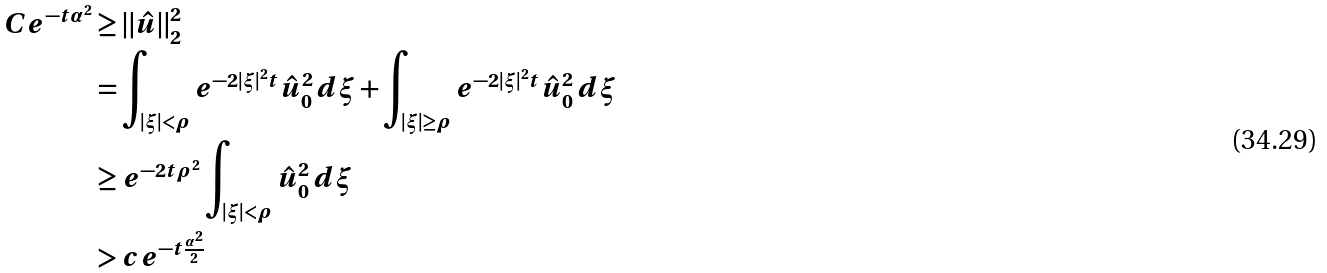<formula> <loc_0><loc_0><loc_500><loc_500>C e ^ { - t \alpha ^ { 2 } } & \geq \| \hat { u } \| _ { 2 } ^ { 2 } \\ & = \int _ { | \xi | < \rho } e ^ { - 2 | \xi | ^ { 2 } t } \hat { u } _ { 0 } ^ { 2 } \, d \xi + \int _ { | \xi | \geq \rho } e ^ { - 2 | \xi | ^ { 2 } t } \hat { u } _ { 0 } ^ { 2 } \, d \xi \\ & \geq e ^ { - 2 t \rho ^ { 2 } } \int _ { | \xi | < \rho } \hat { u } _ { 0 } ^ { 2 } \, d \xi \\ & > c e ^ { - t \frac { \alpha ^ { 2 } } { 2 } }</formula> 